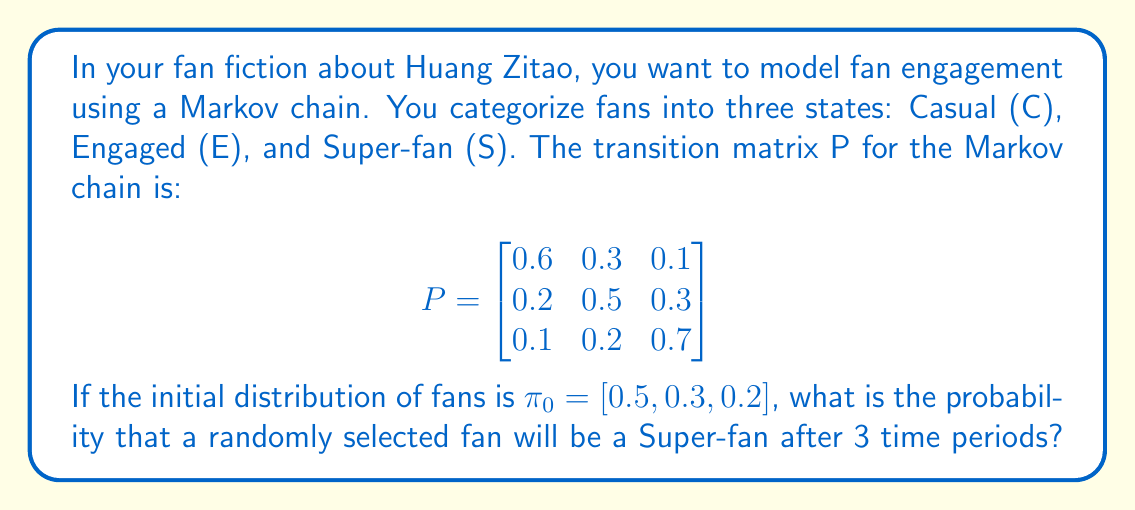Give your solution to this math problem. To solve this problem, we need to follow these steps:

1) The initial distribution is given as $\pi_0 = [0.5, 0.3, 0.2]$.

2) We need to calculate $\pi_3 = \pi_0 P^3$, where $P^3$ is the transition matrix P multiplied by itself 3 times.

3) Let's calculate $P^2$ first:

   $$P^2 = P \cdot P = \begin{bmatrix}
   0.43 & 0.33 & 0.24 \\
   0.31 & 0.37 & 0.32 \\
   0.22 & 0.28 & 0.50
   \end{bmatrix}$$

4) Now, let's calculate $P^3$:

   $$P^3 = P^2 \cdot P = \begin{bmatrix}
   0.367 & 0.333 & 0.300 \\
   0.313 & 0.334 & 0.353 \\
   0.271 & 0.305 & 0.424
   \end{bmatrix}$$

5) Now we can calculate $\pi_3$:

   $$\pi_3 = \pi_0 P^3 = [0.5, 0.3, 0.2] \cdot \begin{bmatrix}
   0.367 & 0.333 & 0.300 \\
   0.313 & 0.334 & 0.353 \\
   0.271 & 0.305 & 0.424
   \end{bmatrix}$$

6) Multiplying these matrices:

   $$\pi_3 = [0.3385, 0.3265, 0.3350]$$

7) The probability of being a Super-fan after 3 time periods is the third element of $\pi_3$, which is 0.3350 or approximately 0.335.
Answer: 0.335 